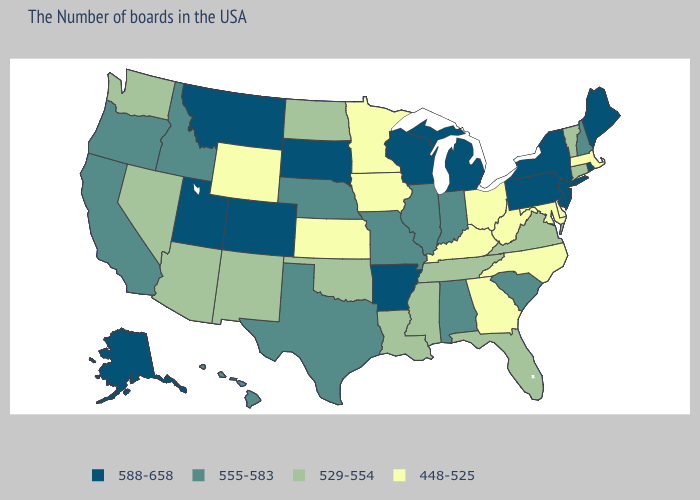Name the states that have a value in the range 555-583?
Be succinct. New Hampshire, South Carolina, Indiana, Alabama, Illinois, Missouri, Nebraska, Texas, Idaho, California, Oregon, Hawaii. Does West Virginia have a lower value than Massachusetts?
Concise answer only. No. Name the states that have a value in the range 555-583?
Concise answer only. New Hampshire, South Carolina, Indiana, Alabama, Illinois, Missouri, Nebraska, Texas, Idaho, California, Oregon, Hawaii. Name the states that have a value in the range 529-554?
Keep it brief. Vermont, Connecticut, Virginia, Florida, Tennessee, Mississippi, Louisiana, Oklahoma, North Dakota, New Mexico, Arizona, Nevada, Washington. Name the states that have a value in the range 448-525?
Concise answer only. Massachusetts, Delaware, Maryland, North Carolina, West Virginia, Ohio, Georgia, Kentucky, Minnesota, Iowa, Kansas, Wyoming. What is the highest value in the Northeast ?
Short answer required. 588-658. What is the lowest value in the West?
Be succinct. 448-525. Which states have the highest value in the USA?
Write a very short answer. Maine, Rhode Island, New York, New Jersey, Pennsylvania, Michigan, Wisconsin, Arkansas, South Dakota, Colorado, Utah, Montana, Alaska. Is the legend a continuous bar?
Give a very brief answer. No. Which states have the highest value in the USA?
Keep it brief. Maine, Rhode Island, New York, New Jersey, Pennsylvania, Michigan, Wisconsin, Arkansas, South Dakota, Colorado, Utah, Montana, Alaska. Name the states that have a value in the range 588-658?
Be succinct. Maine, Rhode Island, New York, New Jersey, Pennsylvania, Michigan, Wisconsin, Arkansas, South Dakota, Colorado, Utah, Montana, Alaska. What is the value of Ohio?
Concise answer only. 448-525. What is the lowest value in the USA?
Short answer required. 448-525. Does the first symbol in the legend represent the smallest category?
Write a very short answer. No. Does South Dakota have the highest value in the MidWest?
Answer briefly. Yes. 